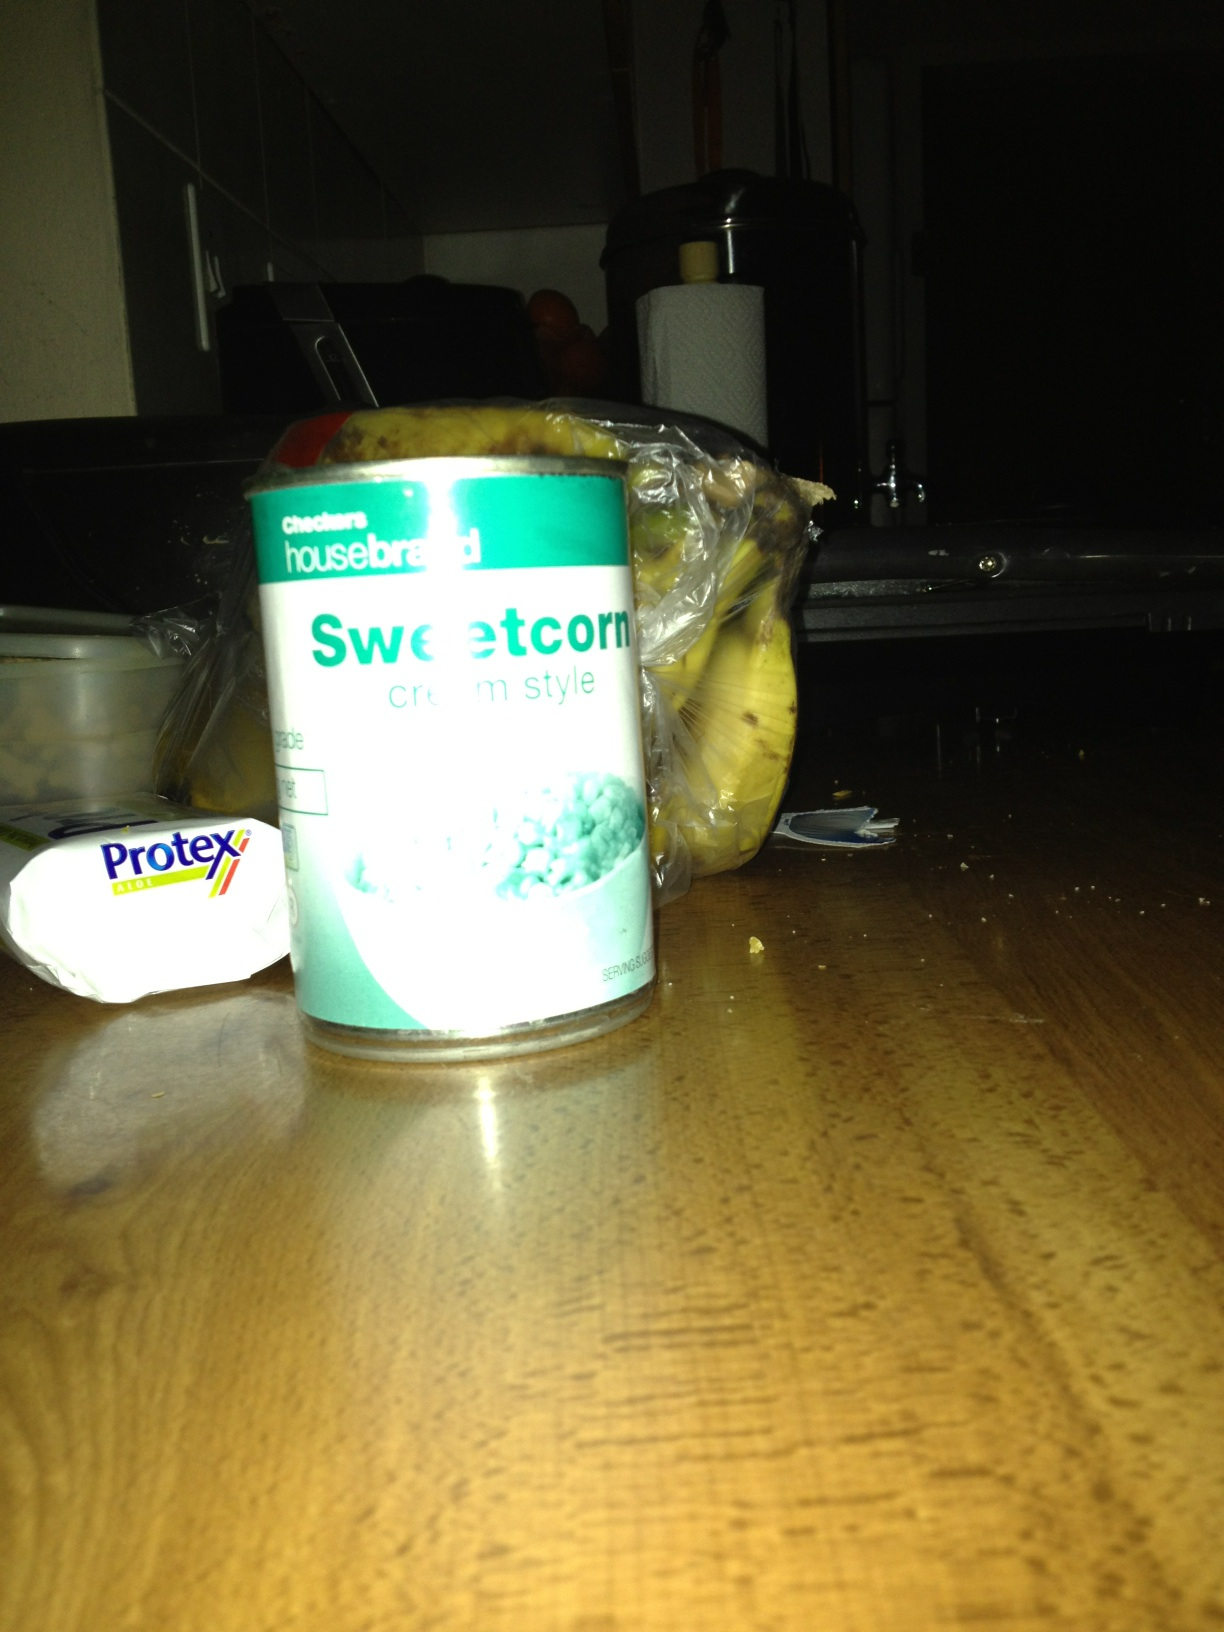Imagine sweetcorn is a magical ingredient in a fairy tale world. What can it do there? In a magical fairy tale world, sweetcorn is known as the 'Golden Corn of Abundance'. Once consumed, it grants the eater enhanced vitality and the power to make plants around them grow instantaneously. Farmers seek this enchanted corn to revive barren lands and ensure bountiful harvests for their villages. Legends say that just a handful of these magical sweetcorn kernels is enough to create a flourishing garden overnight, attracting mythical creatures who thrive in magical environments brimming with life. 